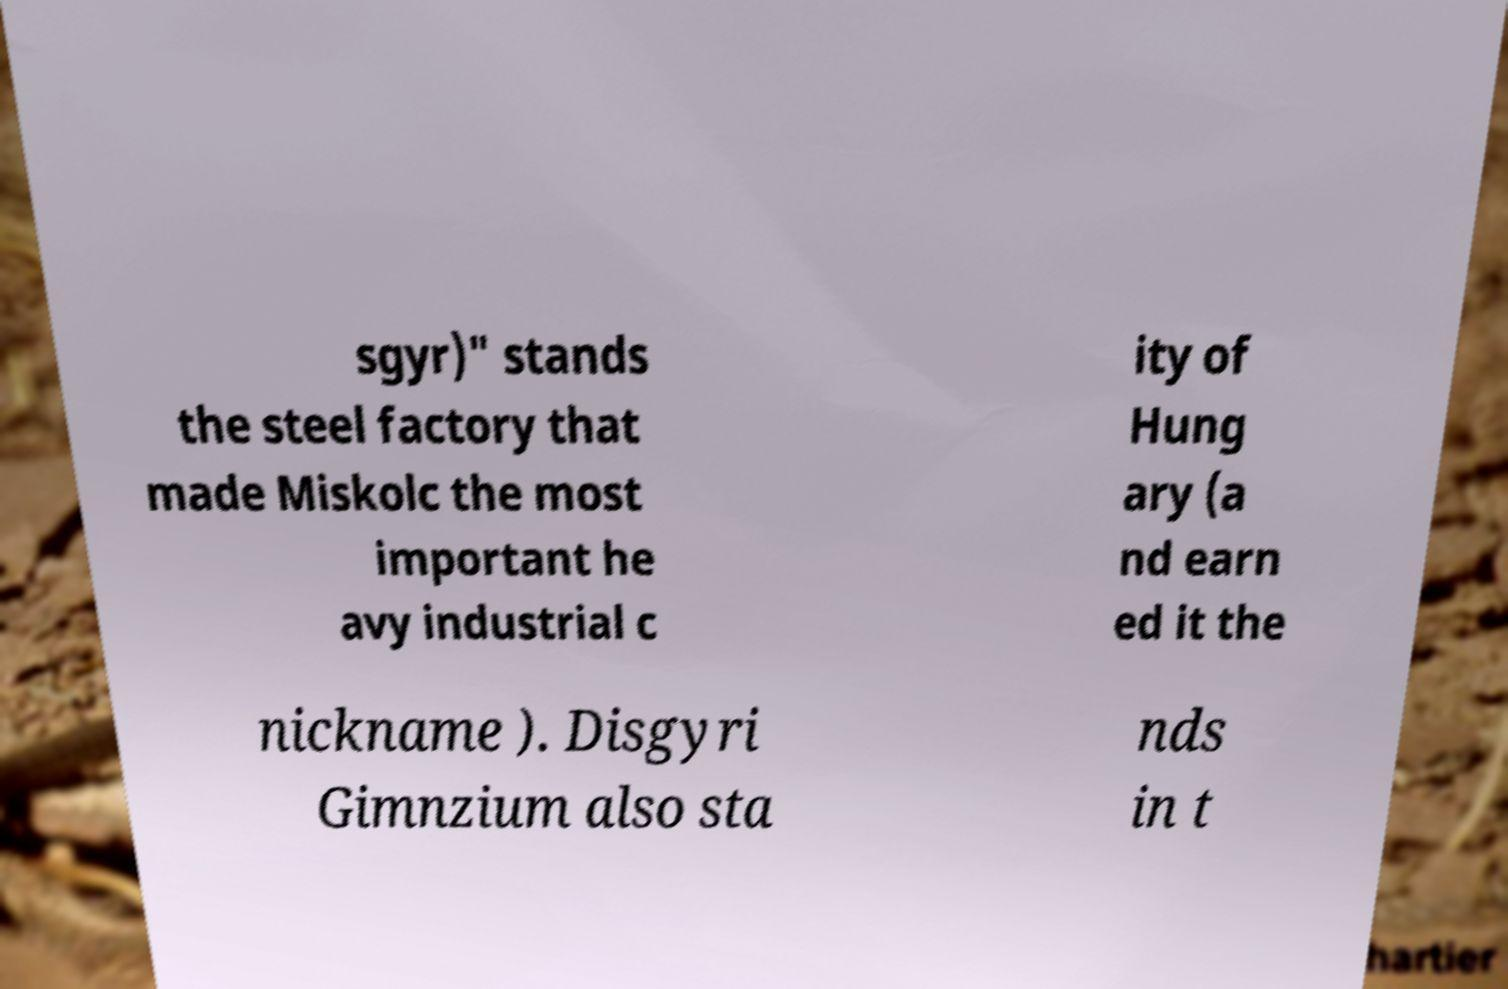Can you read and provide the text displayed in the image?This photo seems to have some interesting text. Can you extract and type it out for me? sgyr)" stands the steel factory that made Miskolc the most important he avy industrial c ity of Hung ary (a nd earn ed it the nickname ). Disgyri Gimnzium also sta nds in t 